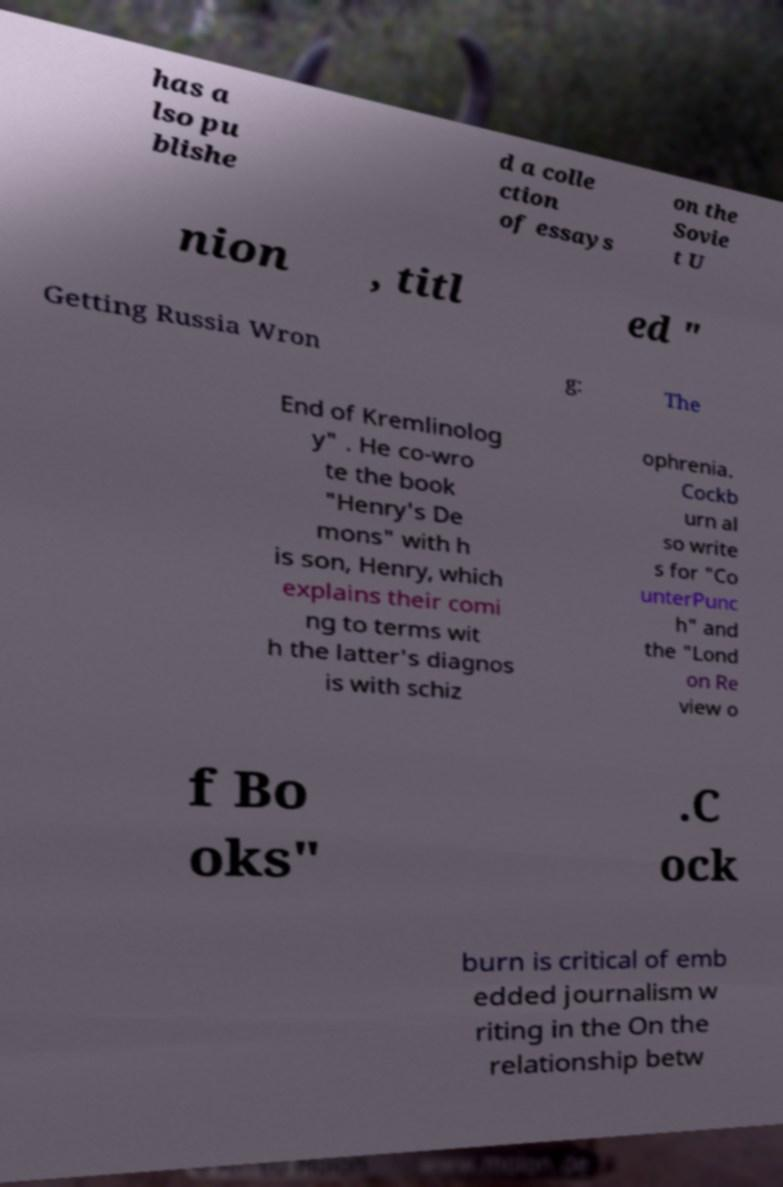Could you assist in decoding the text presented in this image and type it out clearly? has a lso pu blishe d a colle ction of essays on the Sovie t U nion , titl ed " Getting Russia Wron g: The End of Kremlinolog y" . He co-wro te the book "Henry's De mons" with h is son, Henry, which explains their comi ng to terms wit h the latter's diagnos is with schiz ophrenia. Cockb urn al so write s for "Co unterPunc h" and the "Lond on Re view o f Bo oks" .C ock burn is critical of emb edded journalism w riting in the On the relationship betw 